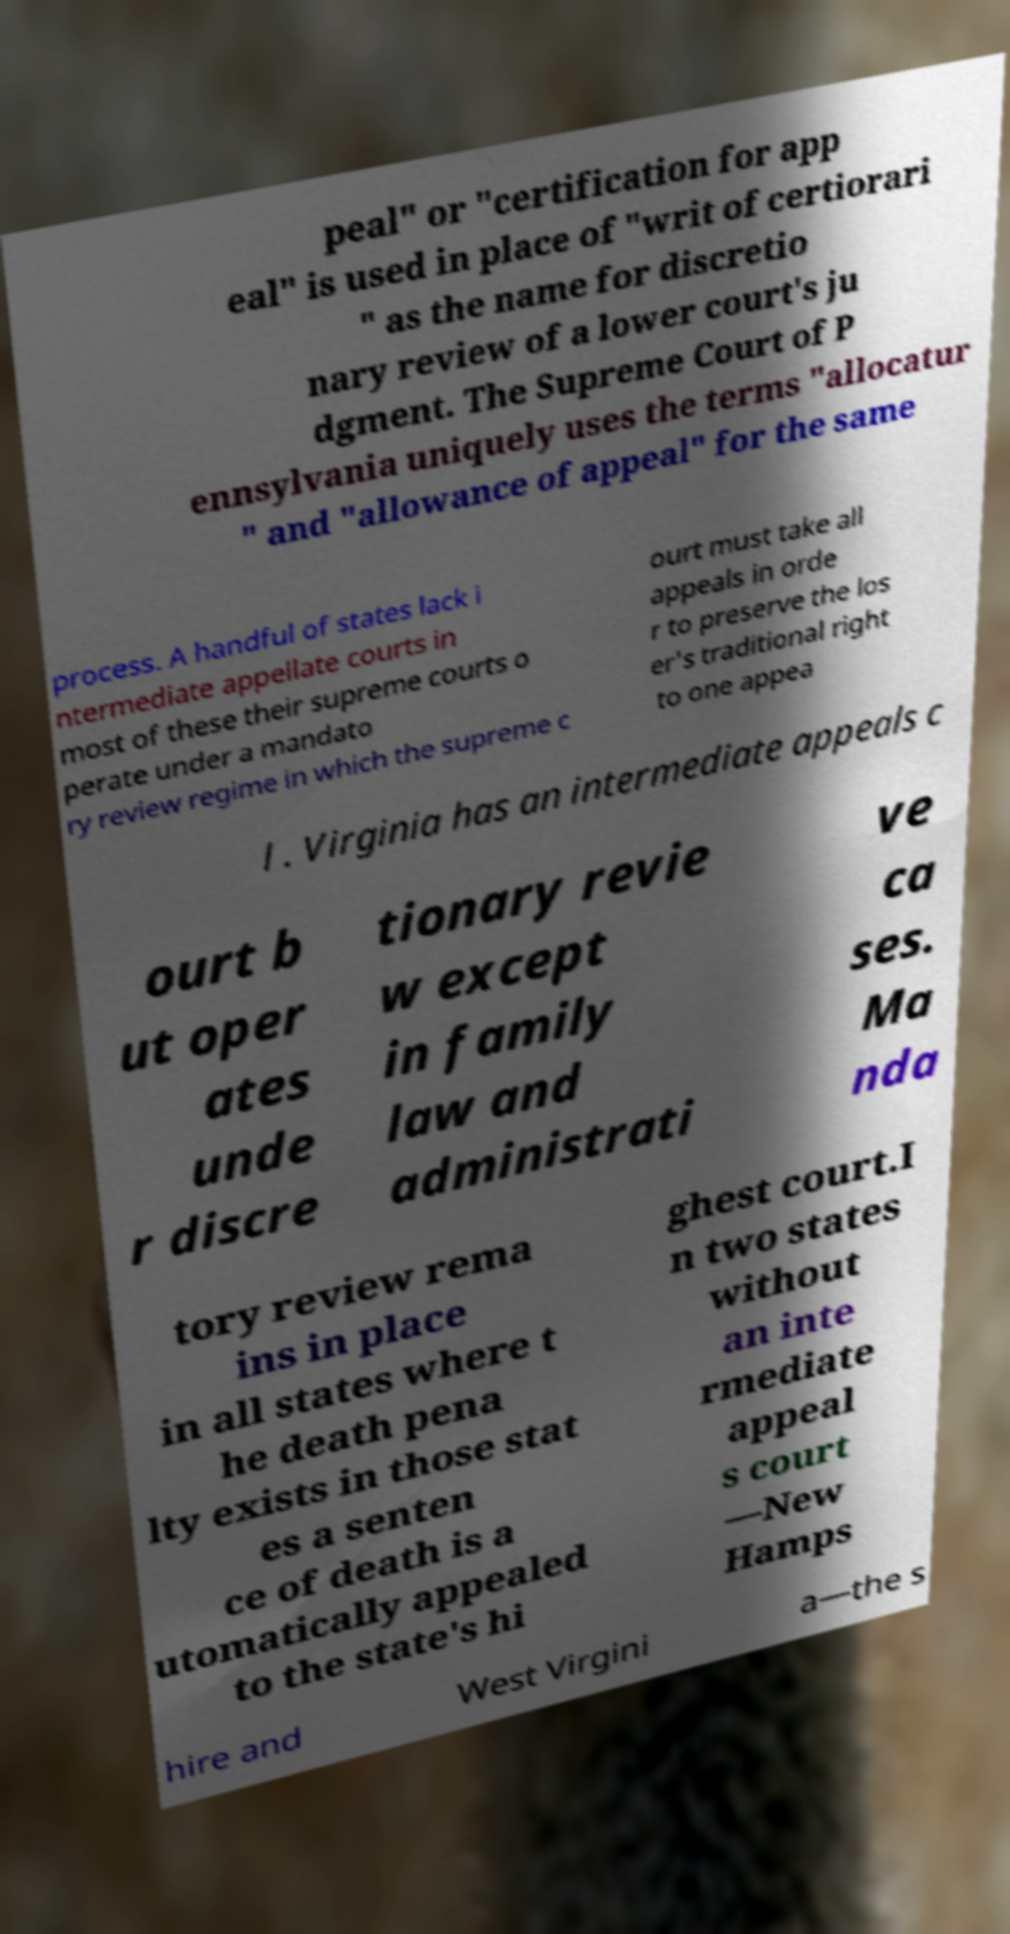Please read and relay the text visible in this image. What does it say? peal" or "certification for app eal" is used in place of "writ of certiorari " as the name for discretio nary review of a lower court's ju dgment. The Supreme Court of P ennsylvania uniquely uses the terms "allocatur " and "allowance of appeal" for the same process. A handful of states lack i ntermediate appellate courts in most of these their supreme courts o perate under a mandato ry review regime in which the supreme c ourt must take all appeals in orde r to preserve the los er's traditional right to one appea l . Virginia has an intermediate appeals c ourt b ut oper ates unde r discre tionary revie w except in family law and administrati ve ca ses. Ma nda tory review rema ins in place in all states where t he death pena lty exists in those stat es a senten ce of death is a utomatically appealed to the state's hi ghest court.I n two states without an inte rmediate appeal s court —New Hamps hire and West Virgini a—the s 